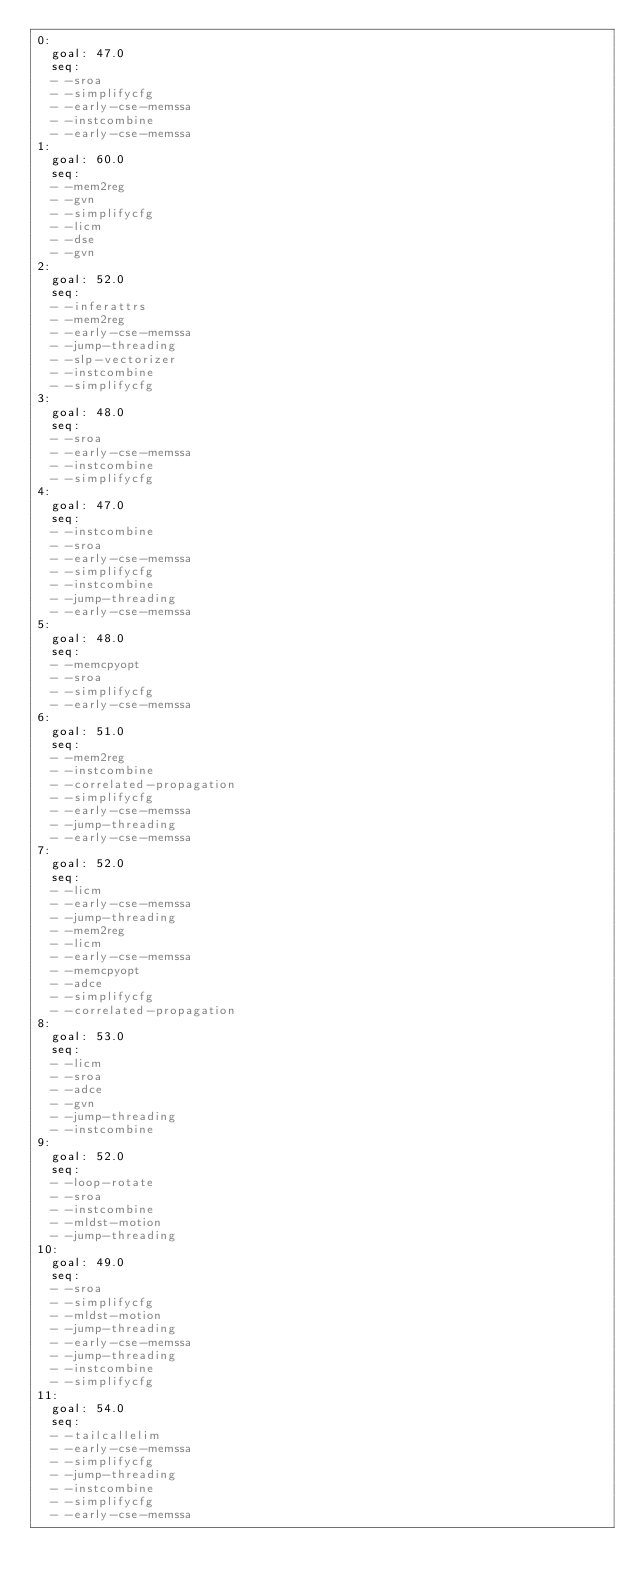<code> <loc_0><loc_0><loc_500><loc_500><_YAML_>0:
  goal: 47.0
  seq:
  - -sroa
  - -simplifycfg
  - -early-cse-memssa
  - -instcombine
  - -early-cse-memssa
1:
  goal: 60.0
  seq:
  - -mem2reg
  - -gvn
  - -simplifycfg
  - -licm
  - -dse
  - -gvn
2:
  goal: 52.0
  seq:
  - -inferattrs
  - -mem2reg
  - -early-cse-memssa
  - -jump-threading
  - -slp-vectorizer
  - -instcombine
  - -simplifycfg
3:
  goal: 48.0
  seq:
  - -sroa
  - -early-cse-memssa
  - -instcombine
  - -simplifycfg
4:
  goal: 47.0
  seq:
  - -instcombine
  - -sroa
  - -early-cse-memssa
  - -simplifycfg
  - -instcombine
  - -jump-threading
  - -early-cse-memssa
5:
  goal: 48.0
  seq:
  - -memcpyopt
  - -sroa
  - -simplifycfg
  - -early-cse-memssa
6:
  goal: 51.0
  seq:
  - -mem2reg
  - -instcombine
  - -correlated-propagation
  - -simplifycfg
  - -early-cse-memssa
  - -jump-threading
  - -early-cse-memssa
7:
  goal: 52.0
  seq:
  - -licm
  - -early-cse-memssa
  - -jump-threading
  - -mem2reg
  - -licm
  - -early-cse-memssa
  - -memcpyopt
  - -adce
  - -simplifycfg
  - -correlated-propagation
8:
  goal: 53.0
  seq:
  - -licm
  - -sroa
  - -adce
  - -gvn
  - -jump-threading
  - -instcombine
9:
  goal: 52.0
  seq:
  - -loop-rotate
  - -sroa
  - -instcombine
  - -mldst-motion
  - -jump-threading
10:
  goal: 49.0
  seq:
  - -sroa
  - -simplifycfg
  - -mldst-motion
  - -jump-threading
  - -early-cse-memssa
  - -jump-threading
  - -instcombine
  - -simplifycfg
11:
  goal: 54.0
  seq:
  - -tailcallelim
  - -early-cse-memssa
  - -simplifycfg
  - -jump-threading
  - -instcombine
  - -simplifycfg
  - -early-cse-memssa</code> 